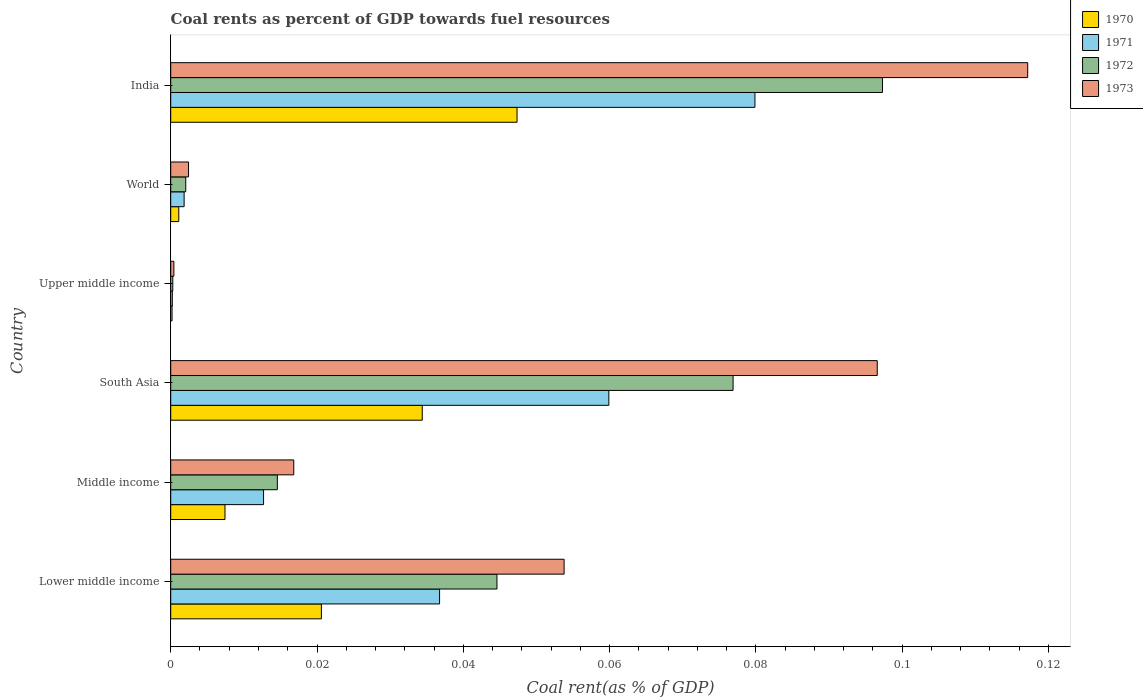How many different coloured bars are there?
Ensure brevity in your answer.  4. How many groups of bars are there?
Give a very brief answer. 6. Are the number of bars on each tick of the Y-axis equal?
Provide a short and direct response. Yes. What is the label of the 3rd group of bars from the top?
Provide a short and direct response. Upper middle income. What is the coal rent in 1973 in India?
Keep it short and to the point. 0.12. Across all countries, what is the maximum coal rent in 1971?
Your answer should be compact. 0.08. Across all countries, what is the minimum coal rent in 1971?
Your answer should be very brief. 0. In which country was the coal rent in 1973 minimum?
Provide a succinct answer. Upper middle income. What is the total coal rent in 1971 in the graph?
Your answer should be compact. 0.19. What is the difference between the coal rent in 1971 in Lower middle income and that in Upper middle income?
Offer a very short reply. 0.04. What is the difference between the coal rent in 1971 in South Asia and the coal rent in 1973 in Lower middle income?
Give a very brief answer. 0.01. What is the average coal rent in 1970 per country?
Offer a very short reply. 0.02. What is the difference between the coal rent in 1971 and coal rent in 1970 in Lower middle income?
Keep it short and to the point. 0.02. In how many countries, is the coal rent in 1972 greater than 0.012 %?
Your answer should be compact. 4. What is the ratio of the coal rent in 1972 in India to that in World?
Keep it short and to the point. 47.35. Is the difference between the coal rent in 1971 in South Asia and World greater than the difference between the coal rent in 1970 in South Asia and World?
Your response must be concise. Yes. What is the difference between the highest and the second highest coal rent in 1970?
Keep it short and to the point. 0.01. What is the difference between the highest and the lowest coal rent in 1970?
Provide a succinct answer. 0.05. In how many countries, is the coal rent in 1970 greater than the average coal rent in 1970 taken over all countries?
Keep it short and to the point. 3. Is the sum of the coal rent in 1972 in India and Upper middle income greater than the maximum coal rent in 1973 across all countries?
Make the answer very short. No. Is it the case that in every country, the sum of the coal rent in 1971 and coal rent in 1972 is greater than the sum of coal rent in 1970 and coal rent in 1973?
Provide a short and direct response. No. What does the 2nd bar from the top in Lower middle income represents?
Give a very brief answer. 1972. What does the 4th bar from the bottom in India represents?
Provide a succinct answer. 1973. Is it the case that in every country, the sum of the coal rent in 1971 and coal rent in 1970 is greater than the coal rent in 1973?
Provide a succinct answer. No. How many countries are there in the graph?
Offer a very short reply. 6. What is the difference between two consecutive major ticks on the X-axis?
Provide a succinct answer. 0.02. Are the values on the major ticks of X-axis written in scientific E-notation?
Offer a very short reply. No. Where does the legend appear in the graph?
Give a very brief answer. Top right. How many legend labels are there?
Give a very brief answer. 4. What is the title of the graph?
Your response must be concise. Coal rents as percent of GDP towards fuel resources. What is the label or title of the X-axis?
Your answer should be compact. Coal rent(as % of GDP). What is the label or title of the Y-axis?
Keep it short and to the point. Country. What is the Coal rent(as % of GDP) of 1970 in Lower middle income?
Your answer should be very brief. 0.02. What is the Coal rent(as % of GDP) of 1971 in Lower middle income?
Ensure brevity in your answer.  0.04. What is the Coal rent(as % of GDP) in 1972 in Lower middle income?
Keep it short and to the point. 0.04. What is the Coal rent(as % of GDP) in 1973 in Lower middle income?
Offer a terse response. 0.05. What is the Coal rent(as % of GDP) in 1970 in Middle income?
Ensure brevity in your answer.  0.01. What is the Coal rent(as % of GDP) of 1971 in Middle income?
Make the answer very short. 0.01. What is the Coal rent(as % of GDP) of 1972 in Middle income?
Keep it short and to the point. 0.01. What is the Coal rent(as % of GDP) in 1973 in Middle income?
Give a very brief answer. 0.02. What is the Coal rent(as % of GDP) in 1970 in South Asia?
Give a very brief answer. 0.03. What is the Coal rent(as % of GDP) in 1971 in South Asia?
Keep it short and to the point. 0.06. What is the Coal rent(as % of GDP) in 1972 in South Asia?
Provide a short and direct response. 0.08. What is the Coal rent(as % of GDP) in 1973 in South Asia?
Your answer should be very brief. 0.1. What is the Coal rent(as % of GDP) of 1970 in Upper middle income?
Your answer should be very brief. 0. What is the Coal rent(as % of GDP) of 1971 in Upper middle income?
Ensure brevity in your answer.  0. What is the Coal rent(as % of GDP) of 1972 in Upper middle income?
Give a very brief answer. 0. What is the Coal rent(as % of GDP) in 1973 in Upper middle income?
Your answer should be very brief. 0. What is the Coal rent(as % of GDP) of 1970 in World?
Your response must be concise. 0. What is the Coal rent(as % of GDP) in 1971 in World?
Keep it short and to the point. 0. What is the Coal rent(as % of GDP) of 1972 in World?
Your response must be concise. 0. What is the Coal rent(as % of GDP) in 1973 in World?
Provide a short and direct response. 0. What is the Coal rent(as % of GDP) in 1970 in India?
Offer a terse response. 0.05. What is the Coal rent(as % of GDP) in 1971 in India?
Ensure brevity in your answer.  0.08. What is the Coal rent(as % of GDP) of 1972 in India?
Your response must be concise. 0.1. What is the Coal rent(as % of GDP) of 1973 in India?
Offer a very short reply. 0.12. Across all countries, what is the maximum Coal rent(as % of GDP) in 1970?
Give a very brief answer. 0.05. Across all countries, what is the maximum Coal rent(as % of GDP) of 1971?
Your answer should be compact. 0.08. Across all countries, what is the maximum Coal rent(as % of GDP) in 1972?
Provide a succinct answer. 0.1. Across all countries, what is the maximum Coal rent(as % of GDP) of 1973?
Provide a short and direct response. 0.12. Across all countries, what is the minimum Coal rent(as % of GDP) in 1970?
Make the answer very short. 0. Across all countries, what is the minimum Coal rent(as % of GDP) in 1971?
Keep it short and to the point. 0. Across all countries, what is the minimum Coal rent(as % of GDP) in 1972?
Provide a short and direct response. 0. Across all countries, what is the minimum Coal rent(as % of GDP) in 1973?
Keep it short and to the point. 0. What is the total Coal rent(as % of GDP) of 1970 in the graph?
Offer a very short reply. 0.11. What is the total Coal rent(as % of GDP) of 1971 in the graph?
Give a very brief answer. 0.19. What is the total Coal rent(as % of GDP) of 1972 in the graph?
Offer a terse response. 0.24. What is the total Coal rent(as % of GDP) of 1973 in the graph?
Ensure brevity in your answer.  0.29. What is the difference between the Coal rent(as % of GDP) of 1970 in Lower middle income and that in Middle income?
Offer a terse response. 0.01. What is the difference between the Coal rent(as % of GDP) in 1971 in Lower middle income and that in Middle income?
Provide a short and direct response. 0.02. What is the difference between the Coal rent(as % of GDP) of 1973 in Lower middle income and that in Middle income?
Keep it short and to the point. 0.04. What is the difference between the Coal rent(as % of GDP) of 1970 in Lower middle income and that in South Asia?
Provide a succinct answer. -0.01. What is the difference between the Coal rent(as % of GDP) of 1971 in Lower middle income and that in South Asia?
Offer a terse response. -0.02. What is the difference between the Coal rent(as % of GDP) of 1972 in Lower middle income and that in South Asia?
Your response must be concise. -0.03. What is the difference between the Coal rent(as % of GDP) of 1973 in Lower middle income and that in South Asia?
Offer a terse response. -0.04. What is the difference between the Coal rent(as % of GDP) in 1970 in Lower middle income and that in Upper middle income?
Offer a terse response. 0.02. What is the difference between the Coal rent(as % of GDP) in 1971 in Lower middle income and that in Upper middle income?
Your answer should be compact. 0.04. What is the difference between the Coal rent(as % of GDP) in 1972 in Lower middle income and that in Upper middle income?
Provide a short and direct response. 0.04. What is the difference between the Coal rent(as % of GDP) in 1973 in Lower middle income and that in Upper middle income?
Your answer should be very brief. 0.05. What is the difference between the Coal rent(as % of GDP) of 1970 in Lower middle income and that in World?
Your answer should be very brief. 0.02. What is the difference between the Coal rent(as % of GDP) of 1971 in Lower middle income and that in World?
Offer a terse response. 0.03. What is the difference between the Coal rent(as % of GDP) in 1972 in Lower middle income and that in World?
Your response must be concise. 0.04. What is the difference between the Coal rent(as % of GDP) in 1973 in Lower middle income and that in World?
Offer a very short reply. 0.05. What is the difference between the Coal rent(as % of GDP) in 1970 in Lower middle income and that in India?
Your answer should be very brief. -0.03. What is the difference between the Coal rent(as % of GDP) in 1971 in Lower middle income and that in India?
Offer a terse response. -0.04. What is the difference between the Coal rent(as % of GDP) in 1972 in Lower middle income and that in India?
Keep it short and to the point. -0.05. What is the difference between the Coal rent(as % of GDP) in 1973 in Lower middle income and that in India?
Offer a very short reply. -0.06. What is the difference between the Coal rent(as % of GDP) in 1970 in Middle income and that in South Asia?
Your answer should be compact. -0.03. What is the difference between the Coal rent(as % of GDP) in 1971 in Middle income and that in South Asia?
Provide a short and direct response. -0.05. What is the difference between the Coal rent(as % of GDP) of 1972 in Middle income and that in South Asia?
Keep it short and to the point. -0.06. What is the difference between the Coal rent(as % of GDP) in 1973 in Middle income and that in South Asia?
Provide a short and direct response. -0.08. What is the difference between the Coal rent(as % of GDP) of 1970 in Middle income and that in Upper middle income?
Ensure brevity in your answer.  0.01. What is the difference between the Coal rent(as % of GDP) in 1971 in Middle income and that in Upper middle income?
Provide a short and direct response. 0.01. What is the difference between the Coal rent(as % of GDP) in 1972 in Middle income and that in Upper middle income?
Make the answer very short. 0.01. What is the difference between the Coal rent(as % of GDP) of 1973 in Middle income and that in Upper middle income?
Ensure brevity in your answer.  0.02. What is the difference between the Coal rent(as % of GDP) in 1970 in Middle income and that in World?
Your answer should be very brief. 0.01. What is the difference between the Coal rent(as % of GDP) in 1971 in Middle income and that in World?
Make the answer very short. 0.01. What is the difference between the Coal rent(as % of GDP) of 1972 in Middle income and that in World?
Provide a succinct answer. 0.01. What is the difference between the Coal rent(as % of GDP) in 1973 in Middle income and that in World?
Provide a short and direct response. 0.01. What is the difference between the Coal rent(as % of GDP) in 1970 in Middle income and that in India?
Ensure brevity in your answer.  -0.04. What is the difference between the Coal rent(as % of GDP) of 1971 in Middle income and that in India?
Provide a short and direct response. -0.07. What is the difference between the Coal rent(as % of GDP) of 1972 in Middle income and that in India?
Offer a terse response. -0.08. What is the difference between the Coal rent(as % of GDP) in 1973 in Middle income and that in India?
Ensure brevity in your answer.  -0.1. What is the difference between the Coal rent(as % of GDP) of 1970 in South Asia and that in Upper middle income?
Provide a short and direct response. 0.03. What is the difference between the Coal rent(as % of GDP) of 1971 in South Asia and that in Upper middle income?
Provide a short and direct response. 0.06. What is the difference between the Coal rent(as % of GDP) in 1972 in South Asia and that in Upper middle income?
Offer a very short reply. 0.08. What is the difference between the Coal rent(as % of GDP) of 1973 in South Asia and that in Upper middle income?
Provide a succinct answer. 0.1. What is the difference between the Coal rent(as % of GDP) of 1971 in South Asia and that in World?
Keep it short and to the point. 0.06. What is the difference between the Coal rent(as % of GDP) of 1972 in South Asia and that in World?
Your answer should be very brief. 0.07. What is the difference between the Coal rent(as % of GDP) in 1973 in South Asia and that in World?
Provide a succinct answer. 0.09. What is the difference between the Coal rent(as % of GDP) in 1970 in South Asia and that in India?
Give a very brief answer. -0.01. What is the difference between the Coal rent(as % of GDP) in 1971 in South Asia and that in India?
Offer a very short reply. -0.02. What is the difference between the Coal rent(as % of GDP) of 1972 in South Asia and that in India?
Give a very brief answer. -0.02. What is the difference between the Coal rent(as % of GDP) of 1973 in South Asia and that in India?
Give a very brief answer. -0.02. What is the difference between the Coal rent(as % of GDP) in 1970 in Upper middle income and that in World?
Give a very brief answer. -0. What is the difference between the Coal rent(as % of GDP) in 1971 in Upper middle income and that in World?
Your answer should be very brief. -0. What is the difference between the Coal rent(as % of GDP) of 1972 in Upper middle income and that in World?
Provide a short and direct response. -0. What is the difference between the Coal rent(as % of GDP) in 1973 in Upper middle income and that in World?
Provide a short and direct response. -0. What is the difference between the Coal rent(as % of GDP) in 1970 in Upper middle income and that in India?
Offer a terse response. -0.05. What is the difference between the Coal rent(as % of GDP) of 1971 in Upper middle income and that in India?
Offer a very short reply. -0.08. What is the difference between the Coal rent(as % of GDP) in 1972 in Upper middle income and that in India?
Your answer should be compact. -0.1. What is the difference between the Coal rent(as % of GDP) in 1973 in Upper middle income and that in India?
Your response must be concise. -0.12. What is the difference between the Coal rent(as % of GDP) of 1970 in World and that in India?
Provide a short and direct response. -0.05. What is the difference between the Coal rent(as % of GDP) of 1971 in World and that in India?
Keep it short and to the point. -0.08. What is the difference between the Coal rent(as % of GDP) of 1972 in World and that in India?
Your response must be concise. -0.1. What is the difference between the Coal rent(as % of GDP) of 1973 in World and that in India?
Provide a short and direct response. -0.11. What is the difference between the Coal rent(as % of GDP) of 1970 in Lower middle income and the Coal rent(as % of GDP) of 1971 in Middle income?
Ensure brevity in your answer.  0.01. What is the difference between the Coal rent(as % of GDP) in 1970 in Lower middle income and the Coal rent(as % of GDP) in 1972 in Middle income?
Provide a short and direct response. 0.01. What is the difference between the Coal rent(as % of GDP) in 1970 in Lower middle income and the Coal rent(as % of GDP) in 1973 in Middle income?
Offer a terse response. 0. What is the difference between the Coal rent(as % of GDP) in 1971 in Lower middle income and the Coal rent(as % of GDP) in 1972 in Middle income?
Provide a succinct answer. 0.02. What is the difference between the Coal rent(as % of GDP) of 1971 in Lower middle income and the Coal rent(as % of GDP) of 1973 in Middle income?
Ensure brevity in your answer.  0.02. What is the difference between the Coal rent(as % of GDP) of 1972 in Lower middle income and the Coal rent(as % of GDP) of 1973 in Middle income?
Give a very brief answer. 0.03. What is the difference between the Coal rent(as % of GDP) in 1970 in Lower middle income and the Coal rent(as % of GDP) in 1971 in South Asia?
Your response must be concise. -0.04. What is the difference between the Coal rent(as % of GDP) in 1970 in Lower middle income and the Coal rent(as % of GDP) in 1972 in South Asia?
Your response must be concise. -0.06. What is the difference between the Coal rent(as % of GDP) in 1970 in Lower middle income and the Coal rent(as % of GDP) in 1973 in South Asia?
Offer a terse response. -0.08. What is the difference between the Coal rent(as % of GDP) of 1971 in Lower middle income and the Coal rent(as % of GDP) of 1972 in South Asia?
Make the answer very short. -0.04. What is the difference between the Coal rent(as % of GDP) of 1971 in Lower middle income and the Coal rent(as % of GDP) of 1973 in South Asia?
Make the answer very short. -0.06. What is the difference between the Coal rent(as % of GDP) of 1972 in Lower middle income and the Coal rent(as % of GDP) of 1973 in South Asia?
Your response must be concise. -0.05. What is the difference between the Coal rent(as % of GDP) of 1970 in Lower middle income and the Coal rent(as % of GDP) of 1971 in Upper middle income?
Keep it short and to the point. 0.02. What is the difference between the Coal rent(as % of GDP) in 1970 in Lower middle income and the Coal rent(as % of GDP) in 1972 in Upper middle income?
Your answer should be very brief. 0.02. What is the difference between the Coal rent(as % of GDP) of 1970 in Lower middle income and the Coal rent(as % of GDP) of 1973 in Upper middle income?
Your response must be concise. 0.02. What is the difference between the Coal rent(as % of GDP) in 1971 in Lower middle income and the Coal rent(as % of GDP) in 1972 in Upper middle income?
Provide a succinct answer. 0.04. What is the difference between the Coal rent(as % of GDP) of 1971 in Lower middle income and the Coal rent(as % of GDP) of 1973 in Upper middle income?
Give a very brief answer. 0.04. What is the difference between the Coal rent(as % of GDP) of 1972 in Lower middle income and the Coal rent(as % of GDP) of 1973 in Upper middle income?
Provide a short and direct response. 0.04. What is the difference between the Coal rent(as % of GDP) in 1970 in Lower middle income and the Coal rent(as % of GDP) in 1971 in World?
Provide a short and direct response. 0.02. What is the difference between the Coal rent(as % of GDP) in 1970 in Lower middle income and the Coal rent(as % of GDP) in 1972 in World?
Provide a succinct answer. 0.02. What is the difference between the Coal rent(as % of GDP) of 1970 in Lower middle income and the Coal rent(as % of GDP) of 1973 in World?
Give a very brief answer. 0.02. What is the difference between the Coal rent(as % of GDP) of 1971 in Lower middle income and the Coal rent(as % of GDP) of 1972 in World?
Provide a short and direct response. 0.03. What is the difference between the Coal rent(as % of GDP) of 1971 in Lower middle income and the Coal rent(as % of GDP) of 1973 in World?
Ensure brevity in your answer.  0.03. What is the difference between the Coal rent(as % of GDP) of 1972 in Lower middle income and the Coal rent(as % of GDP) of 1973 in World?
Make the answer very short. 0.04. What is the difference between the Coal rent(as % of GDP) in 1970 in Lower middle income and the Coal rent(as % of GDP) in 1971 in India?
Your answer should be compact. -0.06. What is the difference between the Coal rent(as % of GDP) of 1970 in Lower middle income and the Coal rent(as % of GDP) of 1972 in India?
Provide a short and direct response. -0.08. What is the difference between the Coal rent(as % of GDP) of 1970 in Lower middle income and the Coal rent(as % of GDP) of 1973 in India?
Your response must be concise. -0.1. What is the difference between the Coal rent(as % of GDP) of 1971 in Lower middle income and the Coal rent(as % of GDP) of 1972 in India?
Your answer should be very brief. -0.06. What is the difference between the Coal rent(as % of GDP) of 1971 in Lower middle income and the Coal rent(as % of GDP) of 1973 in India?
Keep it short and to the point. -0.08. What is the difference between the Coal rent(as % of GDP) in 1972 in Lower middle income and the Coal rent(as % of GDP) in 1973 in India?
Make the answer very short. -0.07. What is the difference between the Coal rent(as % of GDP) of 1970 in Middle income and the Coal rent(as % of GDP) of 1971 in South Asia?
Offer a terse response. -0.05. What is the difference between the Coal rent(as % of GDP) in 1970 in Middle income and the Coal rent(as % of GDP) in 1972 in South Asia?
Your answer should be very brief. -0.07. What is the difference between the Coal rent(as % of GDP) in 1970 in Middle income and the Coal rent(as % of GDP) in 1973 in South Asia?
Keep it short and to the point. -0.09. What is the difference between the Coal rent(as % of GDP) of 1971 in Middle income and the Coal rent(as % of GDP) of 1972 in South Asia?
Ensure brevity in your answer.  -0.06. What is the difference between the Coal rent(as % of GDP) of 1971 in Middle income and the Coal rent(as % of GDP) of 1973 in South Asia?
Your answer should be compact. -0.08. What is the difference between the Coal rent(as % of GDP) in 1972 in Middle income and the Coal rent(as % of GDP) in 1973 in South Asia?
Ensure brevity in your answer.  -0.08. What is the difference between the Coal rent(as % of GDP) of 1970 in Middle income and the Coal rent(as % of GDP) of 1971 in Upper middle income?
Offer a very short reply. 0.01. What is the difference between the Coal rent(as % of GDP) in 1970 in Middle income and the Coal rent(as % of GDP) in 1972 in Upper middle income?
Your answer should be very brief. 0.01. What is the difference between the Coal rent(as % of GDP) of 1970 in Middle income and the Coal rent(as % of GDP) of 1973 in Upper middle income?
Provide a succinct answer. 0.01. What is the difference between the Coal rent(as % of GDP) of 1971 in Middle income and the Coal rent(as % of GDP) of 1972 in Upper middle income?
Offer a very short reply. 0.01. What is the difference between the Coal rent(as % of GDP) of 1971 in Middle income and the Coal rent(as % of GDP) of 1973 in Upper middle income?
Your response must be concise. 0.01. What is the difference between the Coal rent(as % of GDP) in 1972 in Middle income and the Coal rent(as % of GDP) in 1973 in Upper middle income?
Offer a very short reply. 0.01. What is the difference between the Coal rent(as % of GDP) in 1970 in Middle income and the Coal rent(as % of GDP) in 1971 in World?
Keep it short and to the point. 0.01. What is the difference between the Coal rent(as % of GDP) in 1970 in Middle income and the Coal rent(as % of GDP) in 1972 in World?
Provide a short and direct response. 0.01. What is the difference between the Coal rent(as % of GDP) of 1970 in Middle income and the Coal rent(as % of GDP) of 1973 in World?
Your response must be concise. 0.01. What is the difference between the Coal rent(as % of GDP) of 1971 in Middle income and the Coal rent(as % of GDP) of 1972 in World?
Ensure brevity in your answer.  0.01. What is the difference between the Coal rent(as % of GDP) in 1971 in Middle income and the Coal rent(as % of GDP) in 1973 in World?
Your response must be concise. 0.01. What is the difference between the Coal rent(as % of GDP) in 1972 in Middle income and the Coal rent(as % of GDP) in 1973 in World?
Provide a succinct answer. 0.01. What is the difference between the Coal rent(as % of GDP) in 1970 in Middle income and the Coal rent(as % of GDP) in 1971 in India?
Provide a succinct answer. -0.07. What is the difference between the Coal rent(as % of GDP) in 1970 in Middle income and the Coal rent(as % of GDP) in 1972 in India?
Provide a succinct answer. -0.09. What is the difference between the Coal rent(as % of GDP) in 1970 in Middle income and the Coal rent(as % of GDP) in 1973 in India?
Make the answer very short. -0.11. What is the difference between the Coal rent(as % of GDP) in 1971 in Middle income and the Coal rent(as % of GDP) in 1972 in India?
Your response must be concise. -0.08. What is the difference between the Coal rent(as % of GDP) of 1971 in Middle income and the Coal rent(as % of GDP) of 1973 in India?
Ensure brevity in your answer.  -0.1. What is the difference between the Coal rent(as % of GDP) in 1972 in Middle income and the Coal rent(as % of GDP) in 1973 in India?
Provide a succinct answer. -0.1. What is the difference between the Coal rent(as % of GDP) in 1970 in South Asia and the Coal rent(as % of GDP) in 1971 in Upper middle income?
Your answer should be compact. 0.03. What is the difference between the Coal rent(as % of GDP) of 1970 in South Asia and the Coal rent(as % of GDP) of 1972 in Upper middle income?
Your response must be concise. 0.03. What is the difference between the Coal rent(as % of GDP) in 1970 in South Asia and the Coal rent(as % of GDP) in 1973 in Upper middle income?
Provide a succinct answer. 0.03. What is the difference between the Coal rent(as % of GDP) in 1971 in South Asia and the Coal rent(as % of GDP) in 1972 in Upper middle income?
Keep it short and to the point. 0.06. What is the difference between the Coal rent(as % of GDP) of 1971 in South Asia and the Coal rent(as % of GDP) of 1973 in Upper middle income?
Ensure brevity in your answer.  0.06. What is the difference between the Coal rent(as % of GDP) in 1972 in South Asia and the Coal rent(as % of GDP) in 1973 in Upper middle income?
Your answer should be very brief. 0.08. What is the difference between the Coal rent(as % of GDP) of 1970 in South Asia and the Coal rent(as % of GDP) of 1971 in World?
Keep it short and to the point. 0.03. What is the difference between the Coal rent(as % of GDP) in 1970 in South Asia and the Coal rent(as % of GDP) in 1972 in World?
Provide a short and direct response. 0.03. What is the difference between the Coal rent(as % of GDP) of 1970 in South Asia and the Coal rent(as % of GDP) of 1973 in World?
Give a very brief answer. 0.03. What is the difference between the Coal rent(as % of GDP) of 1971 in South Asia and the Coal rent(as % of GDP) of 1972 in World?
Ensure brevity in your answer.  0.06. What is the difference between the Coal rent(as % of GDP) of 1971 in South Asia and the Coal rent(as % of GDP) of 1973 in World?
Offer a very short reply. 0.06. What is the difference between the Coal rent(as % of GDP) in 1972 in South Asia and the Coal rent(as % of GDP) in 1973 in World?
Offer a very short reply. 0.07. What is the difference between the Coal rent(as % of GDP) of 1970 in South Asia and the Coal rent(as % of GDP) of 1971 in India?
Keep it short and to the point. -0.05. What is the difference between the Coal rent(as % of GDP) of 1970 in South Asia and the Coal rent(as % of GDP) of 1972 in India?
Offer a terse response. -0.06. What is the difference between the Coal rent(as % of GDP) of 1970 in South Asia and the Coal rent(as % of GDP) of 1973 in India?
Make the answer very short. -0.08. What is the difference between the Coal rent(as % of GDP) of 1971 in South Asia and the Coal rent(as % of GDP) of 1972 in India?
Provide a succinct answer. -0.04. What is the difference between the Coal rent(as % of GDP) of 1971 in South Asia and the Coal rent(as % of GDP) of 1973 in India?
Keep it short and to the point. -0.06. What is the difference between the Coal rent(as % of GDP) of 1972 in South Asia and the Coal rent(as % of GDP) of 1973 in India?
Your answer should be compact. -0.04. What is the difference between the Coal rent(as % of GDP) in 1970 in Upper middle income and the Coal rent(as % of GDP) in 1971 in World?
Ensure brevity in your answer.  -0. What is the difference between the Coal rent(as % of GDP) in 1970 in Upper middle income and the Coal rent(as % of GDP) in 1972 in World?
Offer a very short reply. -0. What is the difference between the Coal rent(as % of GDP) of 1970 in Upper middle income and the Coal rent(as % of GDP) of 1973 in World?
Make the answer very short. -0. What is the difference between the Coal rent(as % of GDP) in 1971 in Upper middle income and the Coal rent(as % of GDP) in 1972 in World?
Make the answer very short. -0. What is the difference between the Coal rent(as % of GDP) in 1971 in Upper middle income and the Coal rent(as % of GDP) in 1973 in World?
Make the answer very short. -0. What is the difference between the Coal rent(as % of GDP) of 1972 in Upper middle income and the Coal rent(as % of GDP) of 1973 in World?
Offer a terse response. -0. What is the difference between the Coal rent(as % of GDP) of 1970 in Upper middle income and the Coal rent(as % of GDP) of 1971 in India?
Ensure brevity in your answer.  -0.08. What is the difference between the Coal rent(as % of GDP) in 1970 in Upper middle income and the Coal rent(as % of GDP) in 1972 in India?
Provide a succinct answer. -0.1. What is the difference between the Coal rent(as % of GDP) in 1970 in Upper middle income and the Coal rent(as % of GDP) in 1973 in India?
Give a very brief answer. -0.12. What is the difference between the Coal rent(as % of GDP) of 1971 in Upper middle income and the Coal rent(as % of GDP) of 1972 in India?
Make the answer very short. -0.1. What is the difference between the Coal rent(as % of GDP) in 1971 in Upper middle income and the Coal rent(as % of GDP) in 1973 in India?
Provide a short and direct response. -0.12. What is the difference between the Coal rent(as % of GDP) of 1972 in Upper middle income and the Coal rent(as % of GDP) of 1973 in India?
Your response must be concise. -0.12. What is the difference between the Coal rent(as % of GDP) of 1970 in World and the Coal rent(as % of GDP) of 1971 in India?
Your answer should be very brief. -0.08. What is the difference between the Coal rent(as % of GDP) of 1970 in World and the Coal rent(as % of GDP) of 1972 in India?
Offer a terse response. -0.1. What is the difference between the Coal rent(as % of GDP) of 1970 in World and the Coal rent(as % of GDP) of 1973 in India?
Offer a very short reply. -0.12. What is the difference between the Coal rent(as % of GDP) in 1971 in World and the Coal rent(as % of GDP) in 1972 in India?
Offer a terse response. -0.1. What is the difference between the Coal rent(as % of GDP) in 1971 in World and the Coal rent(as % of GDP) in 1973 in India?
Make the answer very short. -0.12. What is the difference between the Coal rent(as % of GDP) in 1972 in World and the Coal rent(as % of GDP) in 1973 in India?
Your response must be concise. -0.12. What is the average Coal rent(as % of GDP) of 1970 per country?
Provide a succinct answer. 0.02. What is the average Coal rent(as % of GDP) in 1971 per country?
Provide a short and direct response. 0.03. What is the average Coal rent(as % of GDP) in 1972 per country?
Your answer should be very brief. 0.04. What is the average Coal rent(as % of GDP) of 1973 per country?
Your answer should be very brief. 0.05. What is the difference between the Coal rent(as % of GDP) of 1970 and Coal rent(as % of GDP) of 1971 in Lower middle income?
Your response must be concise. -0.02. What is the difference between the Coal rent(as % of GDP) in 1970 and Coal rent(as % of GDP) in 1972 in Lower middle income?
Your response must be concise. -0.02. What is the difference between the Coal rent(as % of GDP) of 1970 and Coal rent(as % of GDP) of 1973 in Lower middle income?
Provide a short and direct response. -0.03. What is the difference between the Coal rent(as % of GDP) of 1971 and Coal rent(as % of GDP) of 1972 in Lower middle income?
Offer a very short reply. -0.01. What is the difference between the Coal rent(as % of GDP) in 1971 and Coal rent(as % of GDP) in 1973 in Lower middle income?
Offer a very short reply. -0.02. What is the difference between the Coal rent(as % of GDP) in 1972 and Coal rent(as % of GDP) in 1973 in Lower middle income?
Give a very brief answer. -0.01. What is the difference between the Coal rent(as % of GDP) of 1970 and Coal rent(as % of GDP) of 1971 in Middle income?
Your answer should be very brief. -0.01. What is the difference between the Coal rent(as % of GDP) of 1970 and Coal rent(as % of GDP) of 1972 in Middle income?
Your answer should be very brief. -0.01. What is the difference between the Coal rent(as % of GDP) in 1970 and Coal rent(as % of GDP) in 1973 in Middle income?
Make the answer very short. -0.01. What is the difference between the Coal rent(as % of GDP) of 1971 and Coal rent(as % of GDP) of 1972 in Middle income?
Ensure brevity in your answer.  -0. What is the difference between the Coal rent(as % of GDP) of 1971 and Coal rent(as % of GDP) of 1973 in Middle income?
Offer a very short reply. -0. What is the difference between the Coal rent(as % of GDP) in 1972 and Coal rent(as % of GDP) in 1973 in Middle income?
Make the answer very short. -0. What is the difference between the Coal rent(as % of GDP) of 1970 and Coal rent(as % of GDP) of 1971 in South Asia?
Your answer should be very brief. -0.03. What is the difference between the Coal rent(as % of GDP) of 1970 and Coal rent(as % of GDP) of 1972 in South Asia?
Offer a terse response. -0.04. What is the difference between the Coal rent(as % of GDP) of 1970 and Coal rent(as % of GDP) of 1973 in South Asia?
Ensure brevity in your answer.  -0.06. What is the difference between the Coal rent(as % of GDP) in 1971 and Coal rent(as % of GDP) in 1972 in South Asia?
Your response must be concise. -0.02. What is the difference between the Coal rent(as % of GDP) of 1971 and Coal rent(as % of GDP) of 1973 in South Asia?
Give a very brief answer. -0.04. What is the difference between the Coal rent(as % of GDP) of 1972 and Coal rent(as % of GDP) of 1973 in South Asia?
Provide a succinct answer. -0.02. What is the difference between the Coal rent(as % of GDP) in 1970 and Coal rent(as % of GDP) in 1971 in Upper middle income?
Give a very brief answer. -0. What is the difference between the Coal rent(as % of GDP) in 1970 and Coal rent(as % of GDP) in 1972 in Upper middle income?
Ensure brevity in your answer.  -0. What is the difference between the Coal rent(as % of GDP) in 1970 and Coal rent(as % of GDP) in 1973 in Upper middle income?
Your answer should be compact. -0. What is the difference between the Coal rent(as % of GDP) in 1971 and Coal rent(as % of GDP) in 1972 in Upper middle income?
Keep it short and to the point. -0. What is the difference between the Coal rent(as % of GDP) in 1971 and Coal rent(as % of GDP) in 1973 in Upper middle income?
Give a very brief answer. -0. What is the difference between the Coal rent(as % of GDP) of 1972 and Coal rent(as % of GDP) of 1973 in Upper middle income?
Give a very brief answer. -0. What is the difference between the Coal rent(as % of GDP) of 1970 and Coal rent(as % of GDP) of 1971 in World?
Your answer should be compact. -0. What is the difference between the Coal rent(as % of GDP) in 1970 and Coal rent(as % of GDP) in 1972 in World?
Offer a terse response. -0. What is the difference between the Coal rent(as % of GDP) of 1970 and Coal rent(as % of GDP) of 1973 in World?
Your response must be concise. -0. What is the difference between the Coal rent(as % of GDP) in 1971 and Coal rent(as % of GDP) in 1972 in World?
Keep it short and to the point. -0. What is the difference between the Coal rent(as % of GDP) in 1971 and Coal rent(as % of GDP) in 1973 in World?
Ensure brevity in your answer.  -0. What is the difference between the Coal rent(as % of GDP) of 1972 and Coal rent(as % of GDP) of 1973 in World?
Your answer should be compact. -0. What is the difference between the Coal rent(as % of GDP) of 1970 and Coal rent(as % of GDP) of 1971 in India?
Ensure brevity in your answer.  -0.03. What is the difference between the Coal rent(as % of GDP) of 1970 and Coal rent(as % of GDP) of 1973 in India?
Keep it short and to the point. -0.07. What is the difference between the Coal rent(as % of GDP) of 1971 and Coal rent(as % of GDP) of 1972 in India?
Keep it short and to the point. -0.02. What is the difference between the Coal rent(as % of GDP) of 1971 and Coal rent(as % of GDP) of 1973 in India?
Your response must be concise. -0.04. What is the difference between the Coal rent(as % of GDP) of 1972 and Coal rent(as % of GDP) of 1973 in India?
Provide a succinct answer. -0.02. What is the ratio of the Coal rent(as % of GDP) in 1970 in Lower middle income to that in Middle income?
Give a very brief answer. 2.78. What is the ratio of the Coal rent(as % of GDP) in 1971 in Lower middle income to that in Middle income?
Your answer should be compact. 2.9. What is the ratio of the Coal rent(as % of GDP) of 1972 in Lower middle income to that in Middle income?
Your answer should be very brief. 3.06. What is the ratio of the Coal rent(as % of GDP) of 1973 in Lower middle income to that in Middle income?
Offer a very short reply. 3.2. What is the ratio of the Coal rent(as % of GDP) in 1970 in Lower middle income to that in South Asia?
Make the answer very short. 0.6. What is the ratio of the Coal rent(as % of GDP) of 1971 in Lower middle income to that in South Asia?
Ensure brevity in your answer.  0.61. What is the ratio of the Coal rent(as % of GDP) in 1972 in Lower middle income to that in South Asia?
Make the answer very short. 0.58. What is the ratio of the Coal rent(as % of GDP) of 1973 in Lower middle income to that in South Asia?
Offer a terse response. 0.56. What is the ratio of the Coal rent(as % of GDP) in 1970 in Lower middle income to that in Upper middle income?
Offer a very short reply. 112.03. What is the ratio of the Coal rent(as % of GDP) of 1971 in Lower middle income to that in Upper middle income?
Your answer should be very brief. 167.98. What is the ratio of the Coal rent(as % of GDP) of 1972 in Lower middle income to that in Upper middle income?
Give a very brief answer. 156.82. What is the ratio of the Coal rent(as % of GDP) of 1973 in Lower middle income to that in Upper middle income?
Offer a very short reply. 124.82. What is the ratio of the Coal rent(as % of GDP) of 1970 in Lower middle income to that in World?
Keep it short and to the point. 18.71. What is the ratio of the Coal rent(as % of GDP) of 1971 in Lower middle income to that in World?
Ensure brevity in your answer.  20.06. What is the ratio of the Coal rent(as % of GDP) in 1972 in Lower middle income to that in World?
Offer a very short reply. 21.7. What is the ratio of the Coal rent(as % of GDP) in 1973 in Lower middle income to that in World?
Keep it short and to the point. 22.07. What is the ratio of the Coal rent(as % of GDP) of 1970 in Lower middle income to that in India?
Provide a succinct answer. 0.44. What is the ratio of the Coal rent(as % of GDP) of 1971 in Lower middle income to that in India?
Your answer should be very brief. 0.46. What is the ratio of the Coal rent(as % of GDP) in 1972 in Lower middle income to that in India?
Your response must be concise. 0.46. What is the ratio of the Coal rent(as % of GDP) in 1973 in Lower middle income to that in India?
Provide a succinct answer. 0.46. What is the ratio of the Coal rent(as % of GDP) of 1970 in Middle income to that in South Asia?
Offer a very short reply. 0.22. What is the ratio of the Coal rent(as % of GDP) in 1971 in Middle income to that in South Asia?
Provide a short and direct response. 0.21. What is the ratio of the Coal rent(as % of GDP) of 1972 in Middle income to that in South Asia?
Your response must be concise. 0.19. What is the ratio of the Coal rent(as % of GDP) in 1973 in Middle income to that in South Asia?
Keep it short and to the point. 0.17. What is the ratio of the Coal rent(as % of GDP) in 1970 in Middle income to that in Upper middle income?
Make the answer very short. 40.36. What is the ratio of the Coal rent(as % of GDP) in 1971 in Middle income to that in Upper middle income?
Your response must be concise. 58.01. What is the ratio of the Coal rent(as % of GDP) in 1972 in Middle income to that in Upper middle income?
Your answer should be very brief. 51.25. What is the ratio of the Coal rent(as % of GDP) of 1973 in Middle income to that in Upper middle income?
Keep it short and to the point. 39.04. What is the ratio of the Coal rent(as % of GDP) of 1970 in Middle income to that in World?
Give a very brief answer. 6.74. What is the ratio of the Coal rent(as % of GDP) of 1971 in Middle income to that in World?
Your answer should be compact. 6.93. What is the ratio of the Coal rent(as % of GDP) of 1972 in Middle income to that in World?
Offer a terse response. 7.09. What is the ratio of the Coal rent(as % of GDP) of 1973 in Middle income to that in World?
Your answer should be compact. 6.91. What is the ratio of the Coal rent(as % of GDP) in 1970 in Middle income to that in India?
Make the answer very short. 0.16. What is the ratio of the Coal rent(as % of GDP) of 1971 in Middle income to that in India?
Keep it short and to the point. 0.16. What is the ratio of the Coal rent(as % of GDP) of 1972 in Middle income to that in India?
Provide a succinct answer. 0.15. What is the ratio of the Coal rent(as % of GDP) of 1973 in Middle income to that in India?
Make the answer very short. 0.14. What is the ratio of the Coal rent(as % of GDP) in 1970 in South Asia to that in Upper middle income?
Provide a short and direct response. 187.05. What is the ratio of the Coal rent(as % of GDP) of 1971 in South Asia to that in Upper middle income?
Keep it short and to the point. 273.74. What is the ratio of the Coal rent(as % of GDP) in 1972 in South Asia to that in Upper middle income?
Offer a very short reply. 270.32. What is the ratio of the Coal rent(as % of GDP) in 1973 in South Asia to that in Upper middle income?
Ensure brevity in your answer.  224.18. What is the ratio of the Coal rent(as % of GDP) in 1970 in South Asia to that in World?
Provide a short and direct response. 31.24. What is the ratio of the Coal rent(as % of GDP) of 1971 in South Asia to that in World?
Give a very brief answer. 32.69. What is the ratio of the Coal rent(as % of GDP) in 1972 in South Asia to that in World?
Ensure brevity in your answer.  37.41. What is the ratio of the Coal rent(as % of GDP) of 1973 in South Asia to that in World?
Offer a terse response. 39.65. What is the ratio of the Coal rent(as % of GDP) in 1970 in South Asia to that in India?
Give a very brief answer. 0.73. What is the ratio of the Coal rent(as % of GDP) in 1971 in South Asia to that in India?
Provide a succinct answer. 0.75. What is the ratio of the Coal rent(as % of GDP) of 1972 in South Asia to that in India?
Make the answer very short. 0.79. What is the ratio of the Coal rent(as % of GDP) in 1973 in South Asia to that in India?
Offer a terse response. 0.82. What is the ratio of the Coal rent(as % of GDP) of 1970 in Upper middle income to that in World?
Make the answer very short. 0.17. What is the ratio of the Coal rent(as % of GDP) in 1971 in Upper middle income to that in World?
Give a very brief answer. 0.12. What is the ratio of the Coal rent(as % of GDP) of 1972 in Upper middle income to that in World?
Your answer should be very brief. 0.14. What is the ratio of the Coal rent(as % of GDP) in 1973 in Upper middle income to that in World?
Give a very brief answer. 0.18. What is the ratio of the Coal rent(as % of GDP) in 1970 in Upper middle income to that in India?
Provide a succinct answer. 0. What is the ratio of the Coal rent(as % of GDP) of 1971 in Upper middle income to that in India?
Keep it short and to the point. 0. What is the ratio of the Coal rent(as % of GDP) in 1972 in Upper middle income to that in India?
Provide a short and direct response. 0. What is the ratio of the Coal rent(as % of GDP) in 1973 in Upper middle income to that in India?
Your answer should be very brief. 0. What is the ratio of the Coal rent(as % of GDP) of 1970 in World to that in India?
Offer a very short reply. 0.02. What is the ratio of the Coal rent(as % of GDP) of 1971 in World to that in India?
Provide a succinct answer. 0.02. What is the ratio of the Coal rent(as % of GDP) in 1972 in World to that in India?
Give a very brief answer. 0.02. What is the ratio of the Coal rent(as % of GDP) in 1973 in World to that in India?
Ensure brevity in your answer.  0.02. What is the difference between the highest and the second highest Coal rent(as % of GDP) in 1970?
Provide a short and direct response. 0.01. What is the difference between the highest and the second highest Coal rent(as % of GDP) in 1972?
Offer a very short reply. 0.02. What is the difference between the highest and the second highest Coal rent(as % of GDP) in 1973?
Your response must be concise. 0.02. What is the difference between the highest and the lowest Coal rent(as % of GDP) in 1970?
Keep it short and to the point. 0.05. What is the difference between the highest and the lowest Coal rent(as % of GDP) of 1971?
Offer a very short reply. 0.08. What is the difference between the highest and the lowest Coal rent(as % of GDP) in 1972?
Your response must be concise. 0.1. What is the difference between the highest and the lowest Coal rent(as % of GDP) in 1973?
Ensure brevity in your answer.  0.12. 